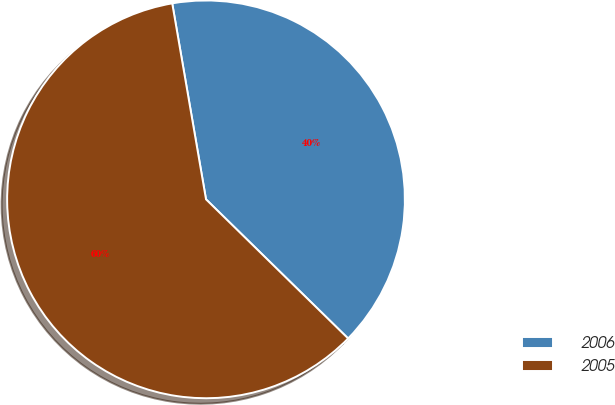Convert chart to OTSL. <chart><loc_0><loc_0><loc_500><loc_500><pie_chart><fcel>2006<fcel>2005<nl><fcel>40.05%<fcel>59.95%<nl></chart> 